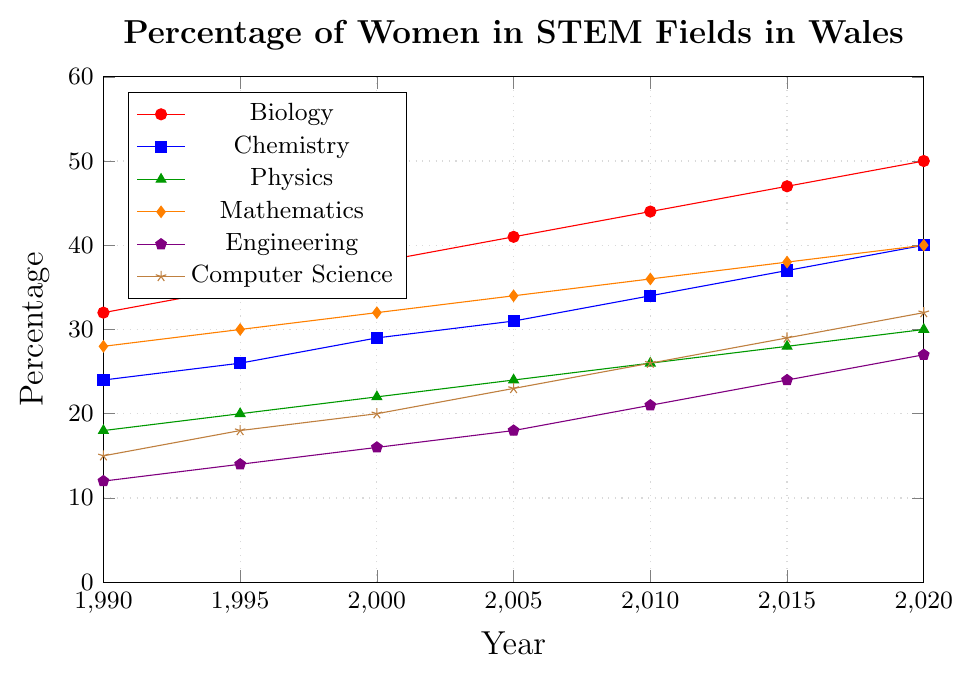Which discipline shows the highest percentage of women in 2020? The plot shows multiple lines for different disciplines. The line for Biology is the highest in 2020, reaching the 50% mark.
Answer: Biology Which discipline has consistently had the lowest percentage of women in STEM from 1990 to 2020? By observing the lines, Engineering starts at 12% in 1990 and stays consistently lower than the others up to 2020.
Answer: Engineering What is the difference in the percentage of women in Computer Science between 1990 and 2020? In 1990, the percentage is 15% and in 2020 it is 32%. The difference is 32% - 15% = 17%.
Answer: 17% Compare the percentage change of women in Chemistry to that in Physics from 1990 to 2020. Chemistry starts at 24% in 1990 and goes to 40% in 2020, an increase of 40 - 24 = 16 percentage points. Physics starts at 18% and goes to 30%, an increase of 30 - 18 = 12 percentage points.
Answer: Chemistry increases by 16 percentage points, Physics by 12 Which fields have shown the same percentage of women in 2020? In 2020, both Mathematics and Chemistry reach 40% as indicated by where the lines for Mathematics and Chemistry meet the y-axis at 40.
Answer: Mathematics and Chemistry In 2000, which discipline had the second highest percentage of women? Referring to the plotted lines at the year 2000, Biology is the highest, followed by Mathematics at 32%.
Answer: Mathematics Calculate the average percentage of women in Biology over the years provided. The percentages are 32, 35, 38, 41, 44, 47, 50. Their sum is 287. There are 7 data points, so average is 287/7.
Answer: 41 Does the trend of women in Engineering show a linear or non-linear increase from 1990 to 2020? Observing the plot, the line representing Engineering shows a steady, linear increase over the years.
Answer: Linear Which discipline had the smallest increase in the percentage of women from 1990 to 2020? The percentage increase is: Biology (18), Chemistry (16), Physics (12), Mathematics (12), Engineering (15), Computer Science (17). The smallest increase is in Physics and Mathematics at 12 percentage points.
Answer: Physics and Mathematics Between 2000 and 2010, which discipline saw the largest absolute increase in the percentage of women? The increase in percentage of women in each discipline from 2000 to 2010 are: Biology (44 - 38 = 6), Chemistry (34 - 29 = 5), Physics (26 - 22 = 4), Mathematics (36 - 32 = 4), Engineering (21 - 16 = 5), Computer Science (26 - 20 = 6). The largest increase happened in Biology and Computer Science with an increase of 6 percentage points each.
Answer: Biology and Computer Science 